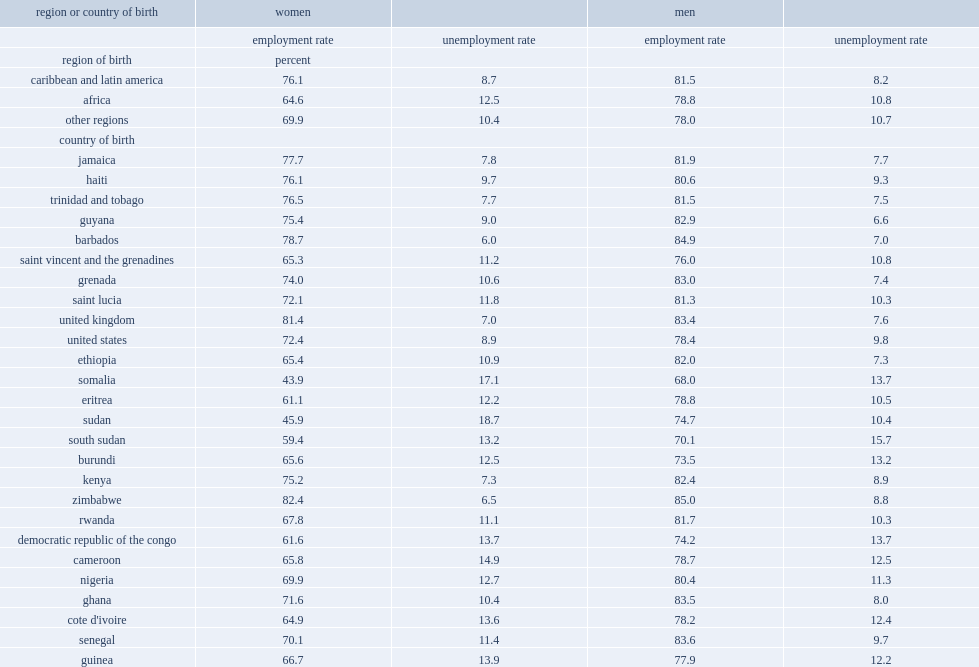Among black immigrant women, which region of birth has a higher the employment rate? women born in the caribbean or in latin america tor women born in africa? Caribbean and latin america. Which top 4 countries of birth had the lowest the lowest employment rates? Democratic republic of the congo nigeria somalia sudan. 